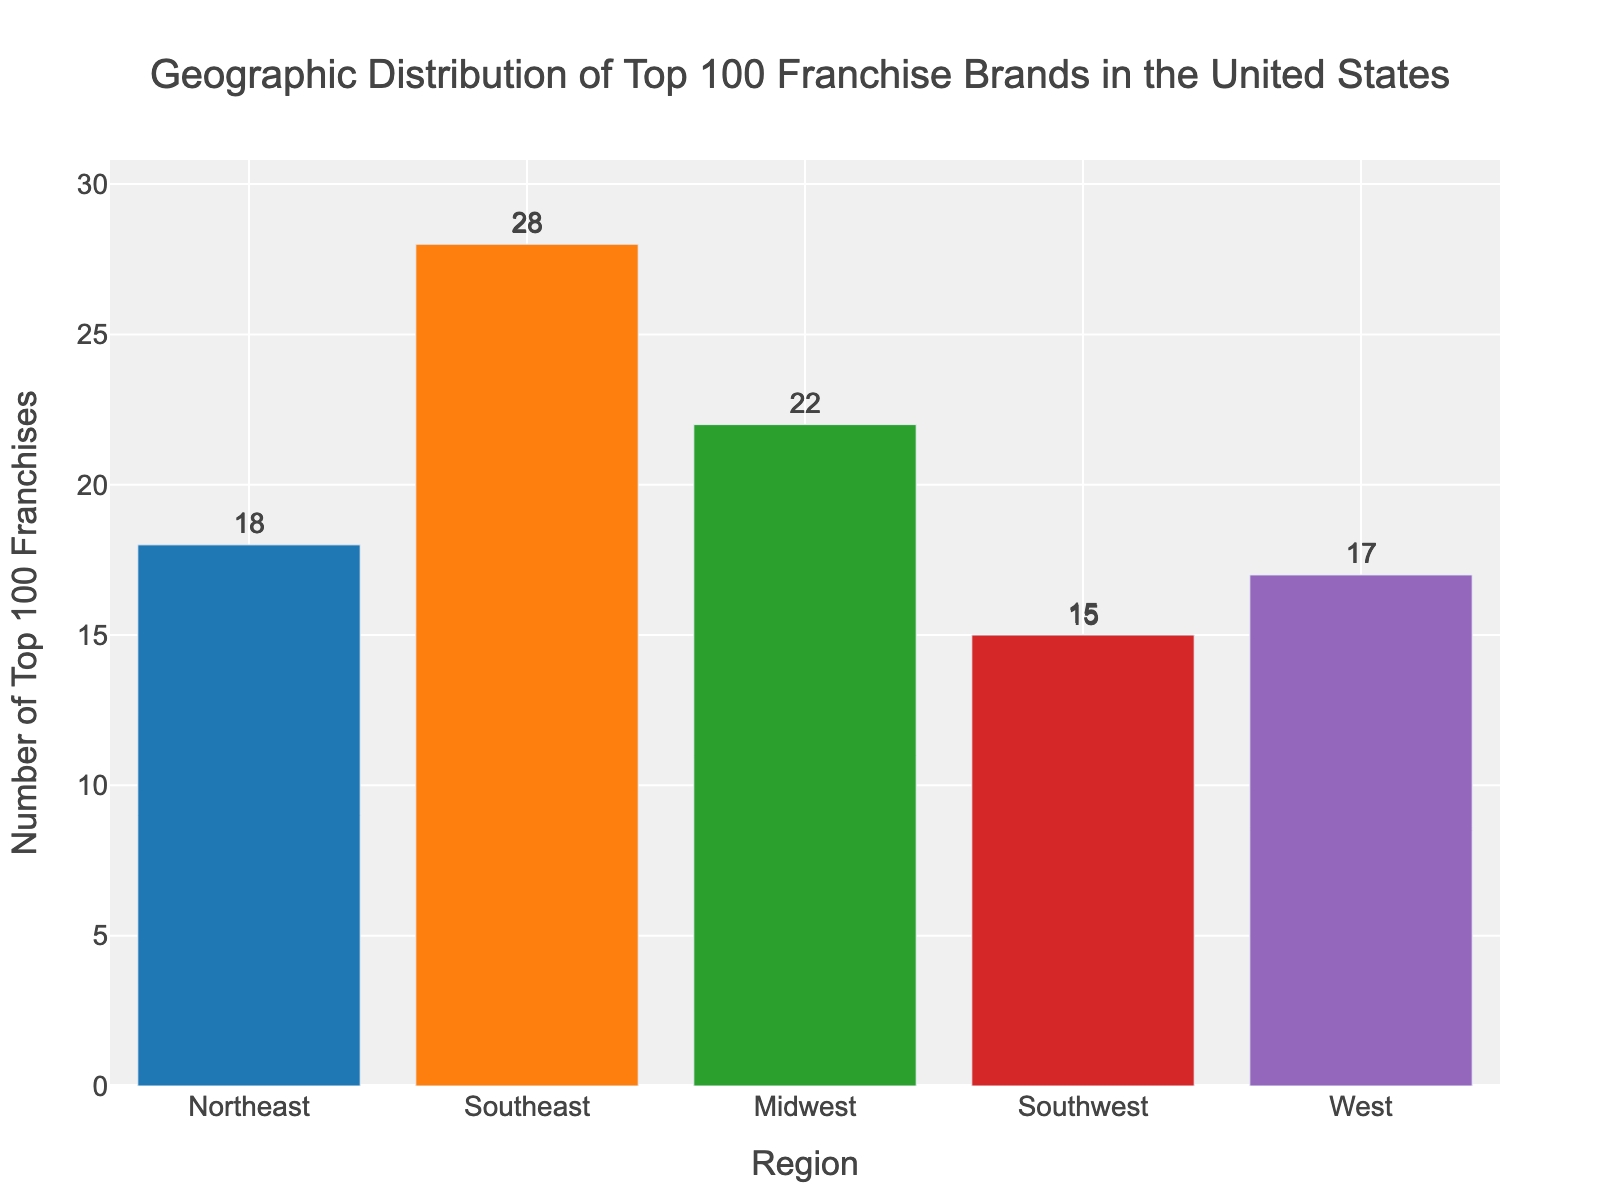Which region has the highest number of top 100 franchises? By looking at the height of the bars, the Southeast region has the tallest bar, indicating that it has the highest number of top 100 franchises. The number indicated is 28.
Answer: Southeast Which region has the lowest number of top 100 franchises? By examining the bar heights and the numbers displayed above each bar, the Southwest region has the shortest bar with 15 franchises.
Answer: Southwest What is the total number of top 100 franchises in the Northeast and West regions combined? Add the number of top 100 franchises in the Northeast (18) to the number in the West (17). 18 + 17 = 35.
Answer: 35 How many more top 100 franchises are there in the Southeast compared to the Southwest? Subtract the number of top 100 franchises in the Southwest (15) from the number in the Southeast (28). 28 - 15 = 13.
Answer: 13 What is the average number of top 100 franchises across all regions? Sum the top 100 franchises across all regions and divide by the number of regions. (18 + 28 + 22 + 15 + 17) / 5 = 100 / 5 = 20.
Answer: 20 Which has a higher number of top 100 franchises, the Midwest or the Northeast? Compare the numbers: the Midwest has 22, and the Northeast has 18. 22 is greater than 18.
Answer: Midwest Is the number of top 100 franchises in the Midwest closer to that in the Southeast or the Northeast? The difference between the Midwest (22) and Northeast (18) is 4. The difference between the Midwest (22) and Southeast (28) is 6. Since 4 is less than 6, the number in the Midwest is closer to the number in the Northeast.
Answer: Northeast How many regions have more than 20 top 100 franchises? Count the regions: Southeast (28) and Midwest (22) each have more than 20 franchises. That's 2 regions.
Answer: 2 What is the difference in the number of top 100 franchises between the West and Southwest regions? Subtract the number of top 100 franchises in the Southwest (15) from the number in the West (17). 17 - 15 = 2.
Answer: 2 